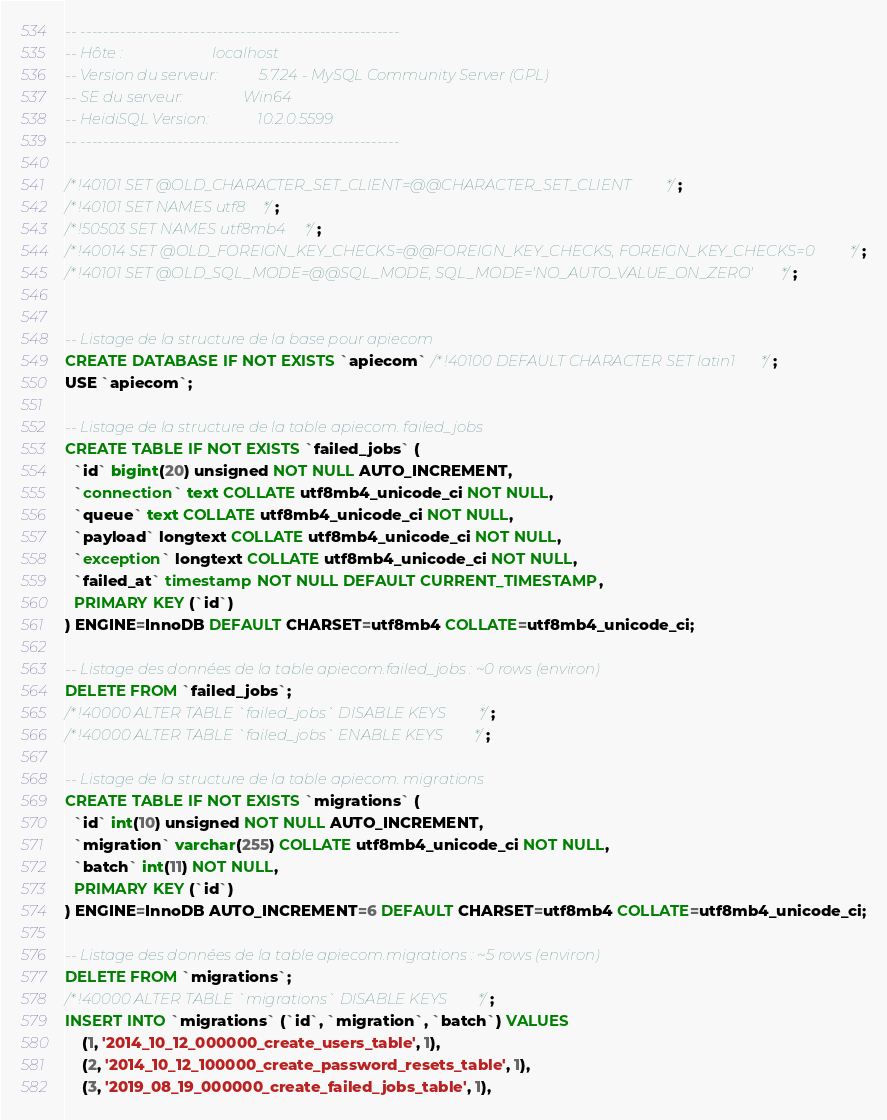Convert code to text. <code><loc_0><loc_0><loc_500><loc_500><_SQL_>-- --------------------------------------------------------
-- Hôte :                        localhost
-- Version du serveur:           5.7.24 - MySQL Community Server (GPL)
-- SE du serveur:                Win64
-- HeidiSQL Version:             10.2.0.5599
-- --------------------------------------------------------

/*!40101 SET @OLD_CHARACTER_SET_CLIENT=@@CHARACTER_SET_CLIENT */;
/*!40101 SET NAMES utf8 */;
/*!50503 SET NAMES utf8mb4 */;
/*!40014 SET @OLD_FOREIGN_KEY_CHECKS=@@FOREIGN_KEY_CHECKS, FOREIGN_KEY_CHECKS=0 */;
/*!40101 SET @OLD_SQL_MODE=@@SQL_MODE, SQL_MODE='NO_AUTO_VALUE_ON_ZERO' */;


-- Listage de la structure de la base pour apiecom
CREATE DATABASE IF NOT EXISTS `apiecom` /*!40100 DEFAULT CHARACTER SET latin1 */;
USE `apiecom`;

-- Listage de la structure de la table apiecom. failed_jobs
CREATE TABLE IF NOT EXISTS `failed_jobs` (
  `id` bigint(20) unsigned NOT NULL AUTO_INCREMENT,
  `connection` text COLLATE utf8mb4_unicode_ci NOT NULL,
  `queue` text COLLATE utf8mb4_unicode_ci NOT NULL,
  `payload` longtext COLLATE utf8mb4_unicode_ci NOT NULL,
  `exception` longtext COLLATE utf8mb4_unicode_ci NOT NULL,
  `failed_at` timestamp NOT NULL DEFAULT CURRENT_TIMESTAMP,
  PRIMARY KEY (`id`)
) ENGINE=InnoDB DEFAULT CHARSET=utf8mb4 COLLATE=utf8mb4_unicode_ci;

-- Listage des données de la table apiecom.failed_jobs : ~0 rows (environ)
DELETE FROM `failed_jobs`;
/*!40000 ALTER TABLE `failed_jobs` DISABLE KEYS */;
/*!40000 ALTER TABLE `failed_jobs` ENABLE KEYS */;

-- Listage de la structure de la table apiecom. migrations
CREATE TABLE IF NOT EXISTS `migrations` (
  `id` int(10) unsigned NOT NULL AUTO_INCREMENT,
  `migration` varchar(255) COLLATE utf8mb4_unicode_ci NOT NULL,
  `batch` int(11) NOT NULL,
  PRIMARY KEY (`id`)
) ENGINE=InnoDB AUTO_INCREMENT=6 DEFAULT CHARSET=utf8mb4 COLLATE=utf8mb4_unicode_ci;

-- Listage des données de la table apiecom.migrations : ~5 rows (environ)
DELETE FROM `migrations`;
/*!40000 ALTER TABLE `migrations` DISABLE KEYS */;
INSERT INTO `migrations` (`id`, `migration`, `batch`) VALUES
	(1, '2014_10_12_000000_create_users_table', 1),
	(2, '2014_10_12_100000_create_password_resets_table', 1),
	(3, '2019_08_19_000000_create_failed_jobs_table', 1),</code> 